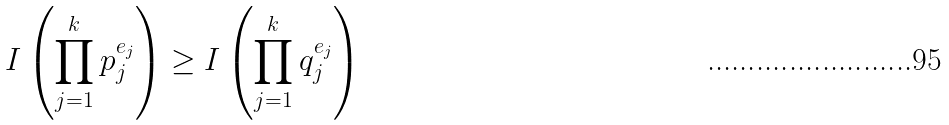Convert formula to latex. <formula><loc_0><loc_0><loc_500><loc_500>I \left ( \prod _ { j = 1 } ^ { k } p _ { j } ^ { e _ { j } } \right ) \geq I \left ( \prod _ { j = 1 } ^ { k } q _ { j } ^ { e _ { j } } \right )</formula> 